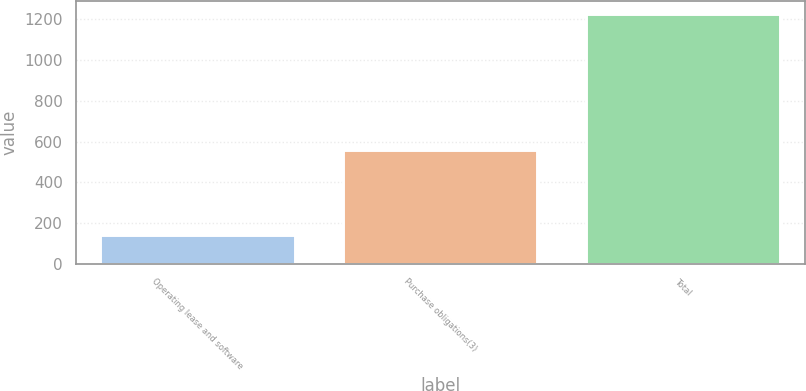Convert chart. <chart><loc_0><loc_0><loc_500><loc_500><bar_chart><fcel>Operating lease and software<fcel>Purchase obligations(3)<fcel>Total<nl><fcel>139.9<fcel>558.9<fcel>1228.1<nl></chart> 